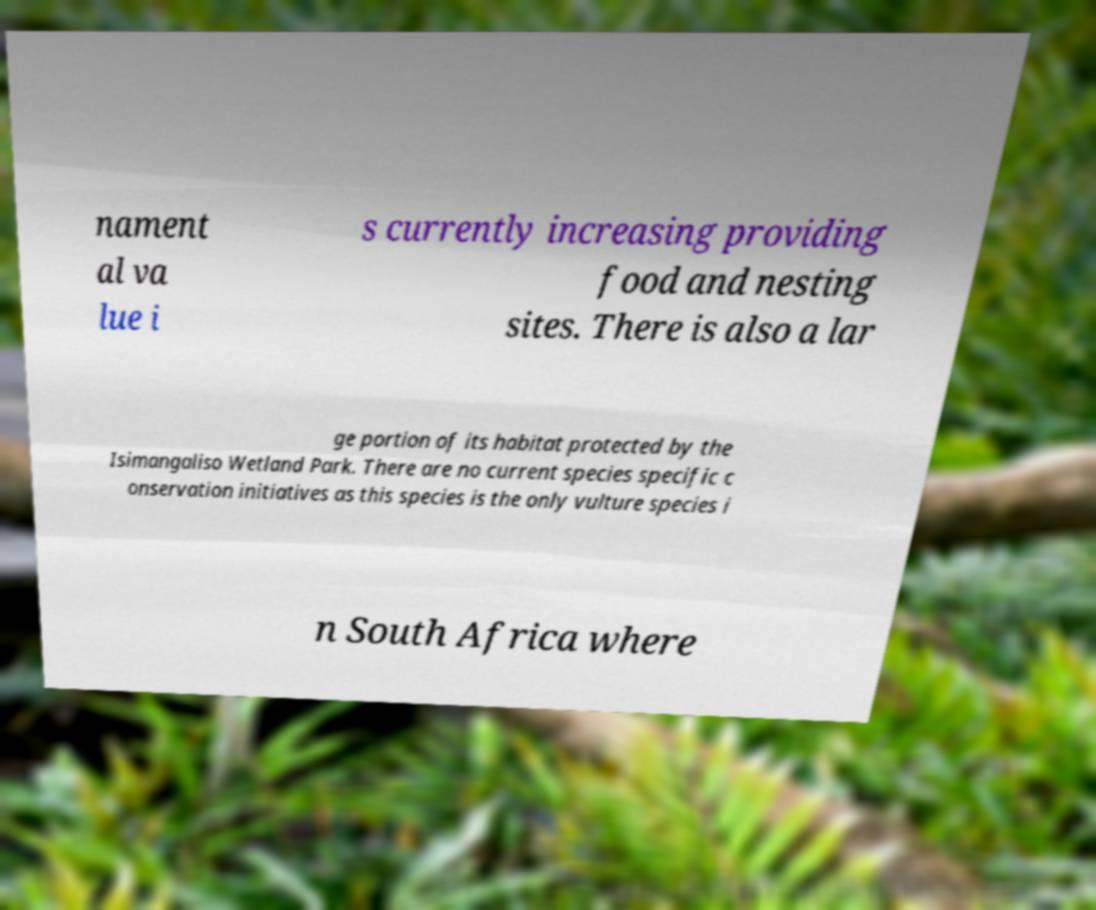Please identify and transcribe the text found in this image. nament al va lue i s currently increasing providing food and nesting sites. There is also a lar ge portion of its habitat protected by the Isimangaliso Wetland Park. There are no current species specific c onservation initiatives as this species is the only vulture species i n South Africa where 